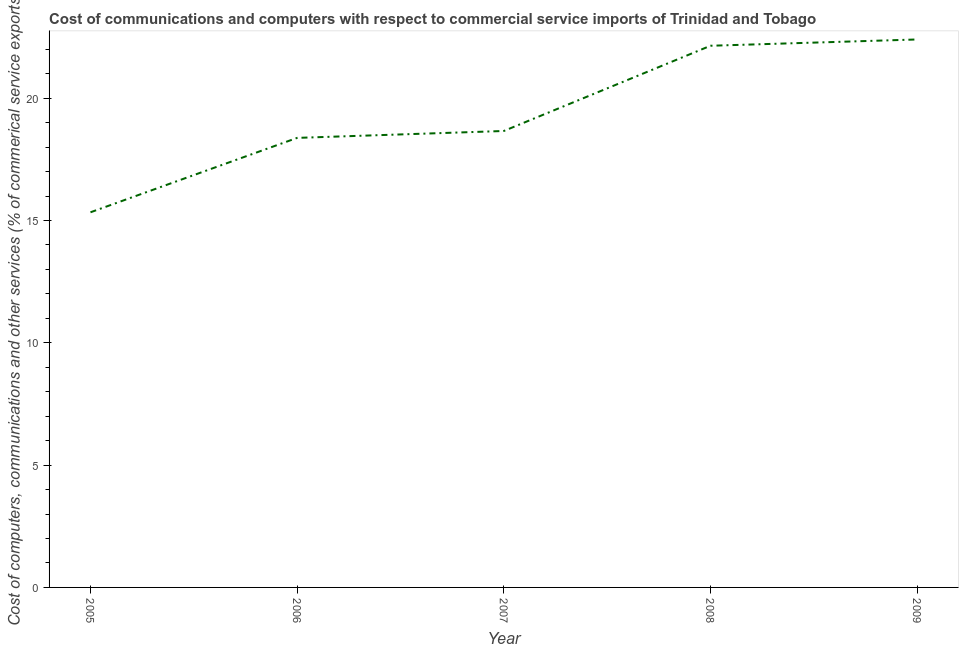What is the cost of communications in 2008?
Offer a very short reply. 22.14. Across all years, what is the maximum cost of communications?
Make the answer very short. 22.4. Across all years, what is the minimum  computer and other services?
Provide a short and direct response. 15.34. In which year was the  computer and other services maximum?
Offer a terse response. 2009. In which year was the cost of communications minimum?
Offer a very short reply. 2005. What is the sum of the  computer and other services?
Offer a very short reply. 96.92. What is the difference between the cost of communications in 2005 and 2009?
Provide a short and direct response. -7.07. What is the average  computer and other services per year?
Provide a succinct answer. 19.38. What is the median cost of communications?
Provide a short and direct response. 18.66. In how many years, is the  computer and other services greater than 21 %?
Your response must be concise. 2. Do a majority of the years between 2009 and 2007 (inclusive) have  computer and other services greater than 5 %?
Keep it short and to the point. No. What is the ratio of the cost of communications in 2006 to that in 2009?
Your answer should be very brief. 0.82. Is the  computer and other services in 2005 less than that in 2008?
Provide a succinct answer. Yes. Is the difference between the cost of communications in 2006 and 2008 greater than the difference between any two years?
Make the answer very short. No. What is the difference between the highest and the second highest cost of communications?
Offer a terse response. 0.26. Is the sum of the cost of communications in 2006 and 2009 greater than the maximum cost of communications across all years?
Offer a very short reply. Yes. What is the difference between the highest and the lowest cost of communications?
Keep it short and to the point. 7.07. How many lines are there?
Give a very brief answer. 1. What is the difference between two consecutive major ticks on the Y-axis?
Make the answer very short. 5. Are the values on the major ticks of Y-axis written in scientific E-notation?
Your response must be concise. No. Does the graph contain grids?
Ensure brevity in your answer.  No. What is the title of the graph?
Offer a very short reply. Cost of communications and computers with respect to commercial service imports of Trinidad and Tobago. What is the label or title of the X-axis?
Keep it short and to the point. Year. What is the label or title of the Y-axis?
Ensure brevity in your answer.  Cost of computers, communications and other services (% of commerical service exports). What is the Cost of computers, communications and other services (% of commerical service exports) in 2005?
Your answer should be compact. 15.34. What is the Cost of computers, communications and other services (% of commerical service exports) of 2006?
Provide a succinct answer. 18.38. What is the Cost of computers, communications and other services (% of commerical service exports) in 2007?
Provide a succinct answer. 18.66. What is the Cost of computers, communications and other services (% of commerical service exports) in 2008?
Keep it short and to the point. 22.14. What is the Cost of computers, communications and other services (% of commerical service exports) in 2009?
Provide a succinct answer. 22.4. What is the difference between the Cost of computers, communications and other services (% of commerical service exports) in 2005 and 2006?
Keep it short and to the point. -3.04. What is the difference between the Cost of computers, communications and other services (% of commerical service exports) in 2005 and 2007?
Make the answer very short. -3.32. What is the difference between the Cost of computers, communications and other services (% of commerical service exports) in 2005 and 2008?
Your answer should be compact. -6.81. What is the difference between the Cost of computers, communications and other services (% of commerical service exports) in 2005 and 2009?
Provide a short and direct response. -7.07. What is the difference between the Cost of computers, communications and other services (% of commerical service exports) in 2006 and 2007?
Offer a very short reply. -0.28. What is the difference between the Cost of computers, communications and other services (% of commerical service exports) in 2006 and 2008?
Keep it short and to the point. -3.77. What is the difference between the Cost of computers, communications and other services (% of commerical service exports) in 2006 and 2009?
Your answer should be very brief. -4.02. What is the difference between the Cost of computers, communications and other services (% of commerical service exports) in 2007 and 2008?
Keep it short and to the point. -3.48. What is the difference between the Cost of computers, communications and other services (% of commerical service exports) in 2007 and 2009?
Ensure brevity in your answer.  -3.74. What is the difference between the Cost of computers, communications and other services (% of commerical service exports) in 2008 and 2009?
Keep it short and to the point. -0.26. What is the ratio of the Cost of computers, communications and other services (% of commerical service exports) in 2005 to that in 2006?
Provide a short and direct response. 0.83. What is the ratio of the Cost of computers, communications and other services (% of commerical service exports) in 2005 to that in 2007?
Provide a succinct answer. 0.82. What is the ratio of the Cost of computers, communications and other services (% of commerical service exports) in 2005 to that in 2008?
Keep it short and to the point. 0.69. What is the ratio of the Cost of computers, communications and other services (% of commerical service exports) in 2005 to that in 2009?
Offer a very short reply. 0.69. What is the ratio of the Cost of computers, communications and other services (% of commerical service exports) in 2006 to that in 2008?
Offer a terse response. 0.83. What is the ratio of the Cost of computers, communications and other services (% of commerical service exports) in 2006 to that in 2009?
Offer a terse response. 0.82. What is the ratio of the Cost of computers, communications and other services (% of commerical service exports) in 2007 to that in 2008?
Ensure brevity in your answer.  0.84. What is the ratio of the Cost of computers, communications and other services (% of commerical service exports) in 2007 to that in 2009?
Offer a very short reply. 0.83. What is the ratio of the Cost of computers, communications and other services (% of commerical service exports) in 2008 to that in 2009?
Make the answer very short. 0.99. 